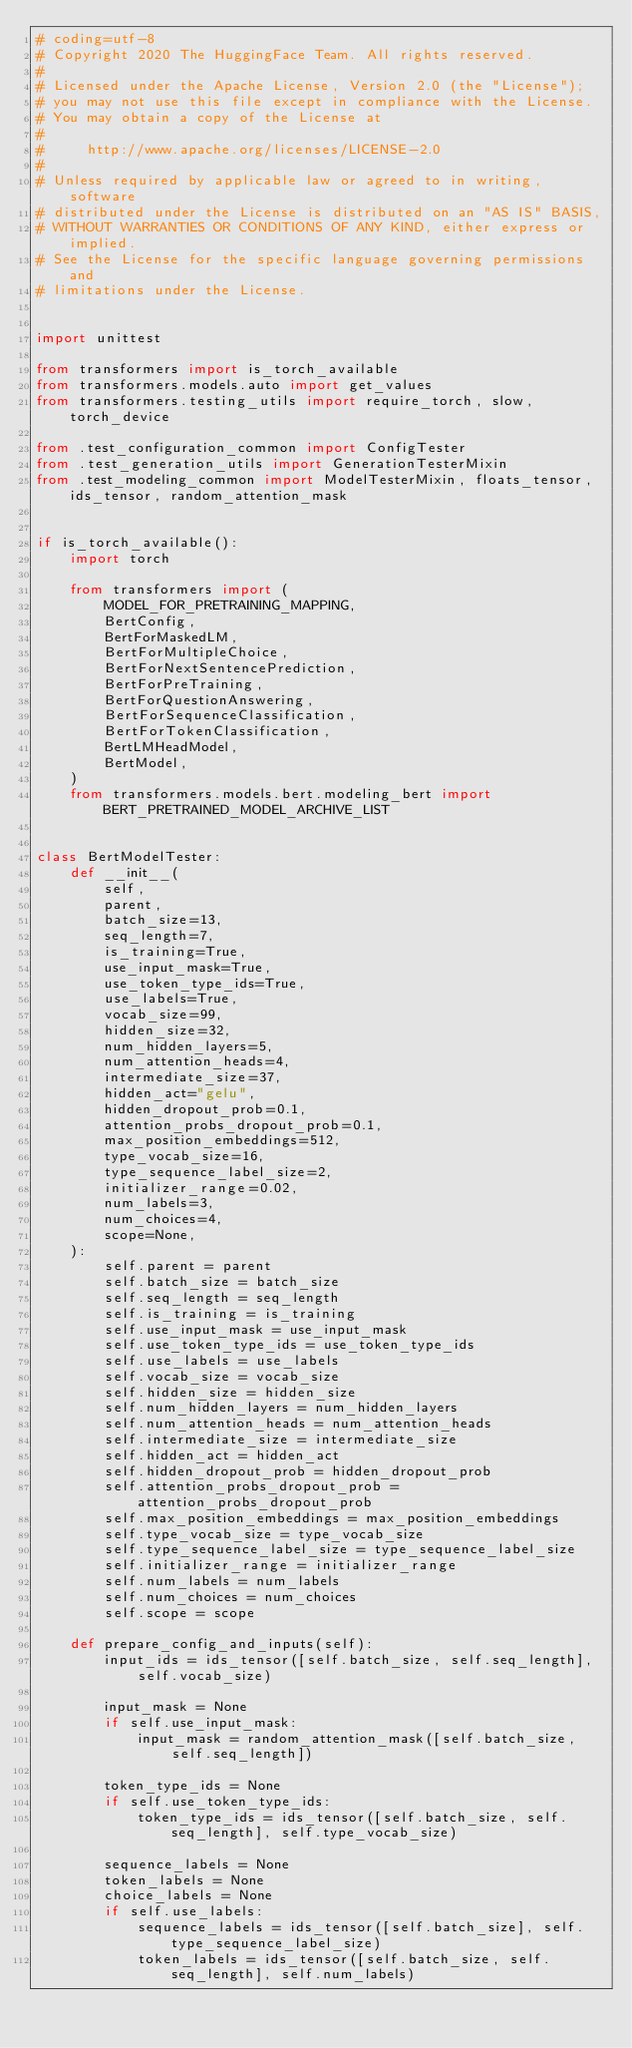<code> <loc_0><loc_0><loc_500><loc_500><_Python_># coding=utf-8
# Copyright 2020 The HuggingFace Team. All rights reserved.
#
# Licensed under the Apache License, Version 2.0 (the "License");
# you may not use this file except in compliance with the License.
# You may obtain a copy of the License at
#
#     http://www.apache.org/licenses/LICENSE-2.0
#
# Unless required by applicable law or agreed to in writing, software
# distributed under the License is distributed on an "AS IS" BASIS,
# WITHOUT WARRANTIES OR CONDITIONS OF ANY KIND, either express or implied.
# See the License for the specific language governing permissions and
# limitations under the License.


import unittest

from transformers import is_torch_available
from transformers.models.auto import get_values
from transformers.testing_utils import require_torch, slow, torch_device

from .test_configuration_common import ConfigTester
from .test_generation_utils import GenerationTesterMixin
from .test_modeling_common import ModelTesterMixin, floats_tensor, ids_tensor, random_attention_mask


if is_torch_available():
    import torch

    from transformers import (
        MODEL_FOR_PRETRAINING_MAPPING,
        BertConfig,
        BertForMaskedLM,
        BertForMultipleChoice,
        BertForNextSentencePrediction,
        BertForPreTraining,
        BertForQuestionAnswering,
        BertForSequenceClassification,
        BertForTokenClassification,
        BertLMHeadModel,
        BertModel,
    )
    from transformers.models.bert.modeling_bert import BERT_PRETRAINED_MODEL_ARCHIVE_LIST


class BertModelTester:
    def __init__(
        self,
        parent,
        batch_size=13,
        seq_length=7,
        is_training=True,
        use_input_mask=True,
        use_token_type_ids=True,
        use_labels=True,
        vocab_size=99,
        hidden_size=32,
        num_hidden_layers=5,
        num_attention_heads=4,
        intermediate_size=37,
        hidden_act="gelu",
        hidden_dropout_prob=0.1,
        attention_probs_dropout_prob=0.1,
        max_position_embeddings=512,
        type_vocab_size=16,
        type_sequence_label_size=2,
        initializer_range=0.02,
        num_labels=3,
        num_choices=4,
        scope=None,
    ):
        self.parent = parent
        self.batch_size = batch_size
        self.seq_length = seq_length
        self.is_training = is_training
        self.use_input_mask = use_input_mask
        self.use_token_type_ids = use_token_type_ids
        self.use_labels = use_labels
        self.vocab_size = vocab_size
        self.hidden_size = hidden_size
        self.num_hidden_layers = num_hidden_layers
        self.num_attention_heads = num_attention_heads
        self.intermediate_size = intermediate_size
        self.hidden_act = hidden_act
        self.hidden_dropout_prob = hidden_dropout_prob
        self.attention_probs_dropout_prob = attention_probs_dropout_prob
        self.max_position_embeddings = max_position_embeddings
        self.type_vocab_size = type_vocab_size
        self.type_sequence_label_size = type_sequence_label_size
        self.initializer_range = initializer_range
        self.num_labels = num_labels
        self.num_choices = num_choices
        self.scope = scope

    def prepare_config_and_inputs(self):
        input_ids = ids_tensor([self.batch_size, self.seq_length], self.vocab_size)

        input_mask = None
        if self.use_input_mask:
            input_mask = random_attention_mask([self.batch_size, self.seq_length])

        token_type_ids = None
        if self.use_token_type_ids:
            token_type_ids = ids_tensor([self.batch_size, self.seq_length], self.type_vocab_size)

        sequence_labels = None
        token_labels = None
        choice_labels = None
        if self.use_labels:
            sequence_labels = ids_tensor([self.batch_size], self.type_sequence_label_size)
            token_labels = ids_tensor([self.batch_size, self.seq_length], self.num_labels)</code> 